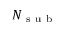<formula> <loc_0><loc_0><loc_500><loc_500>N _ { s u b }</formula> 